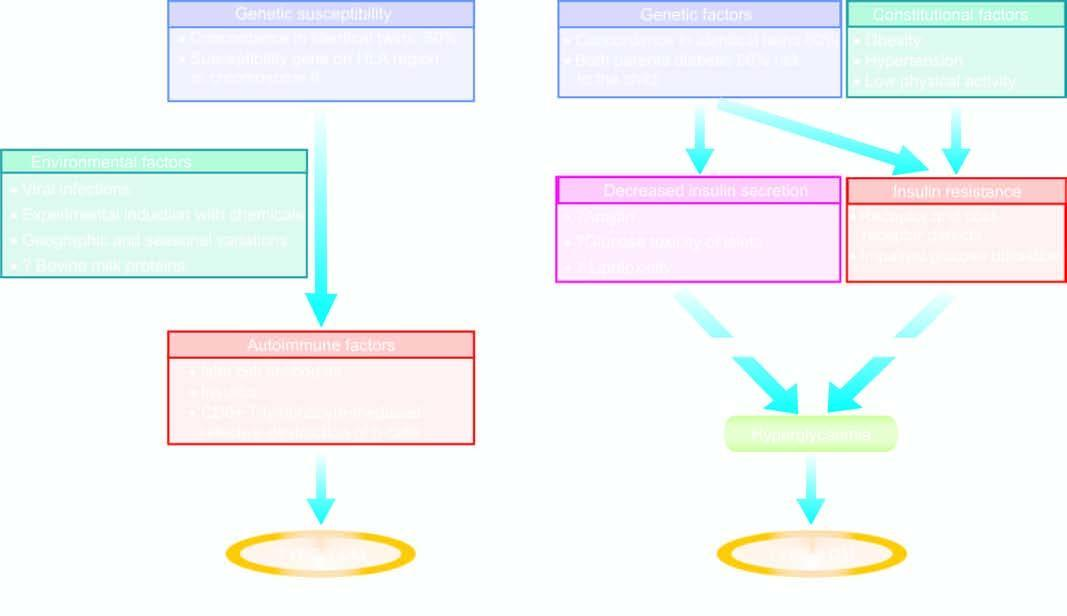re numbers in the illustrations involved in pathogenesis of two main types of diabetes mellitus?
Answer the question using a single word or phrase. No 